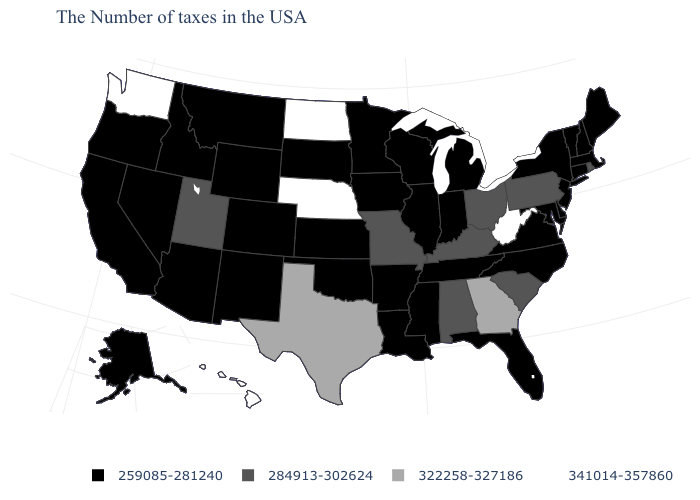What is the value of Arkansas?
Give a very brief answer. 259085-281240. Among the states that border Ohio , which have the highest value?
Answer briefly. West Virginia. What is the highest value in states that border New York?
Quick response, please. 284913-302624. What is the lowest value in the USA?
Give a very brief answer. 259085-281240. Among the states that border Florida , which have the lowest value?
Keep it brief. Alabama. Name the states that have a value in the range 284913-302624?
Give a very brief answer. Rhode Island, Pennsylvania, South Carolina, Ohio, Kentucky, Alabama, Missouri, Utah. Name the states that have a value in the range 341014-357860?
Be succinct. West Virginia, Nebraska, North Dakota, Washington, Hawaii. How many symbols are there in the legend?
Quick response, please. 4. What is the value of Nevada?
Keep it brief. 259085-281240. Which states have the lowest value in the MidWest?
Write a very short answer. Michigan, Indiana, Wisconsin, Illinois, Minnesota, Iowa, Kansas, South Dakota. Does Rhode Island have a lower value than Georgia?
Short answer required. Yes. Does Mississippi have a lower value than Delaware?
Keep it brief. No. Name the states that have a value in the range 341014-357860?
Answer briefly. West Virginia, Nebraska, North Dakota, Washington, Hawaii. Does the first symbol in the legend represent the smallest category?
Short answer required. Yes. 